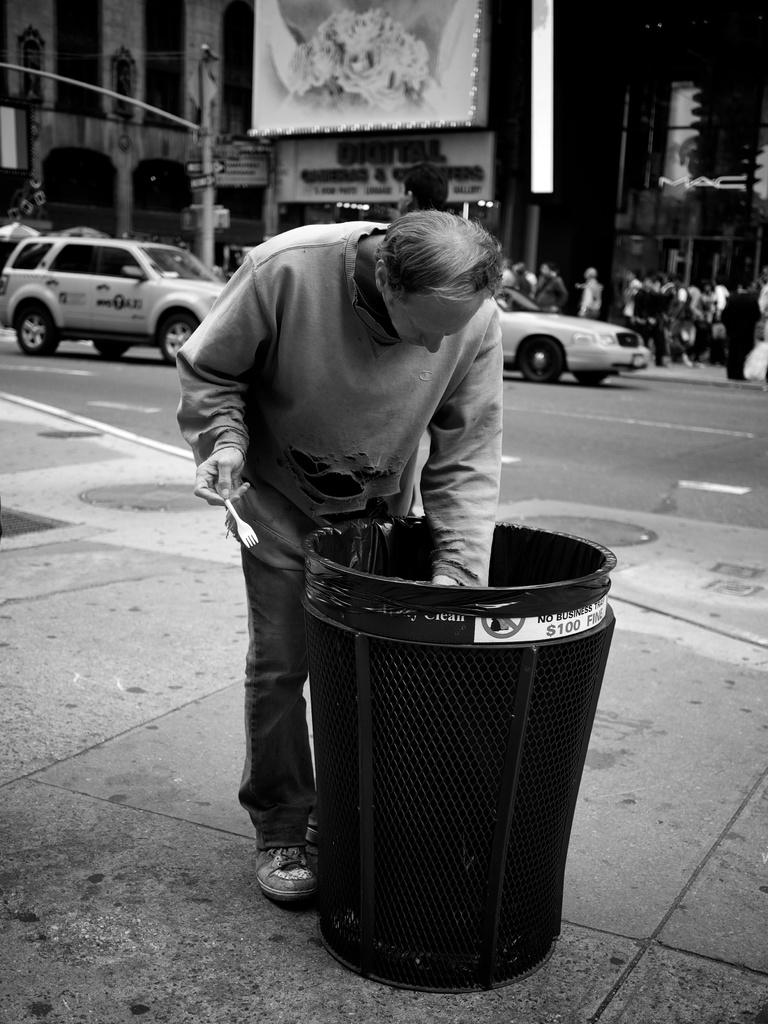<image>
Summarize the visual content of the image. a man is digging in a trash can that has a hundred dollar fine warning posted on the side. 